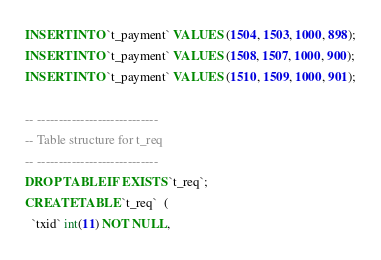Convert code to text. <code><loc_0><loc_0><loc_500><loc_500><_SQL_>INSERT INTO `t_payment` VALUES (1504, 1503, 1000, 898);
INSERT INTO `t_payment` VALUES (1508, 1507, 1000, 900);
INSERT INTO `t_payment` VALUES (1510, 1509, 1000, 901);

-- ----------------------------
-- Table structure for t_req
-- ----------------------------
DROP TABLE IF EXISTS `t_req`;
CREATE TABLE `t_req`  (
  `txid` int(11) NOT NULL,</code> 